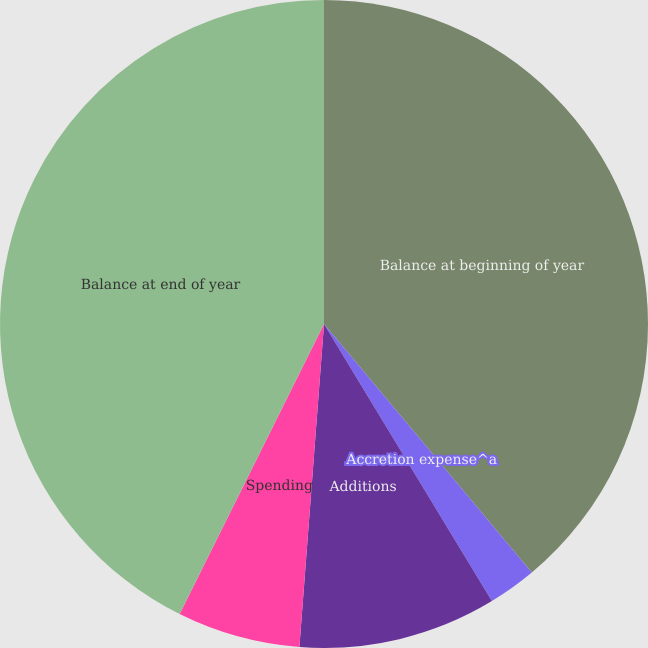<chart> <loc_0><loc_0><loc_500><loc_500><pie_chart><fcel>Balance at beginning of year<fcel>Accretion expense^a<fcel>Additions<fcel>Spending<fcel>Balance at end of year<nl><fcel>38.92%<fcel>2.41%<fcel>9.88%<fcel>6.14%<fcel>42.65%<nl></chart> 